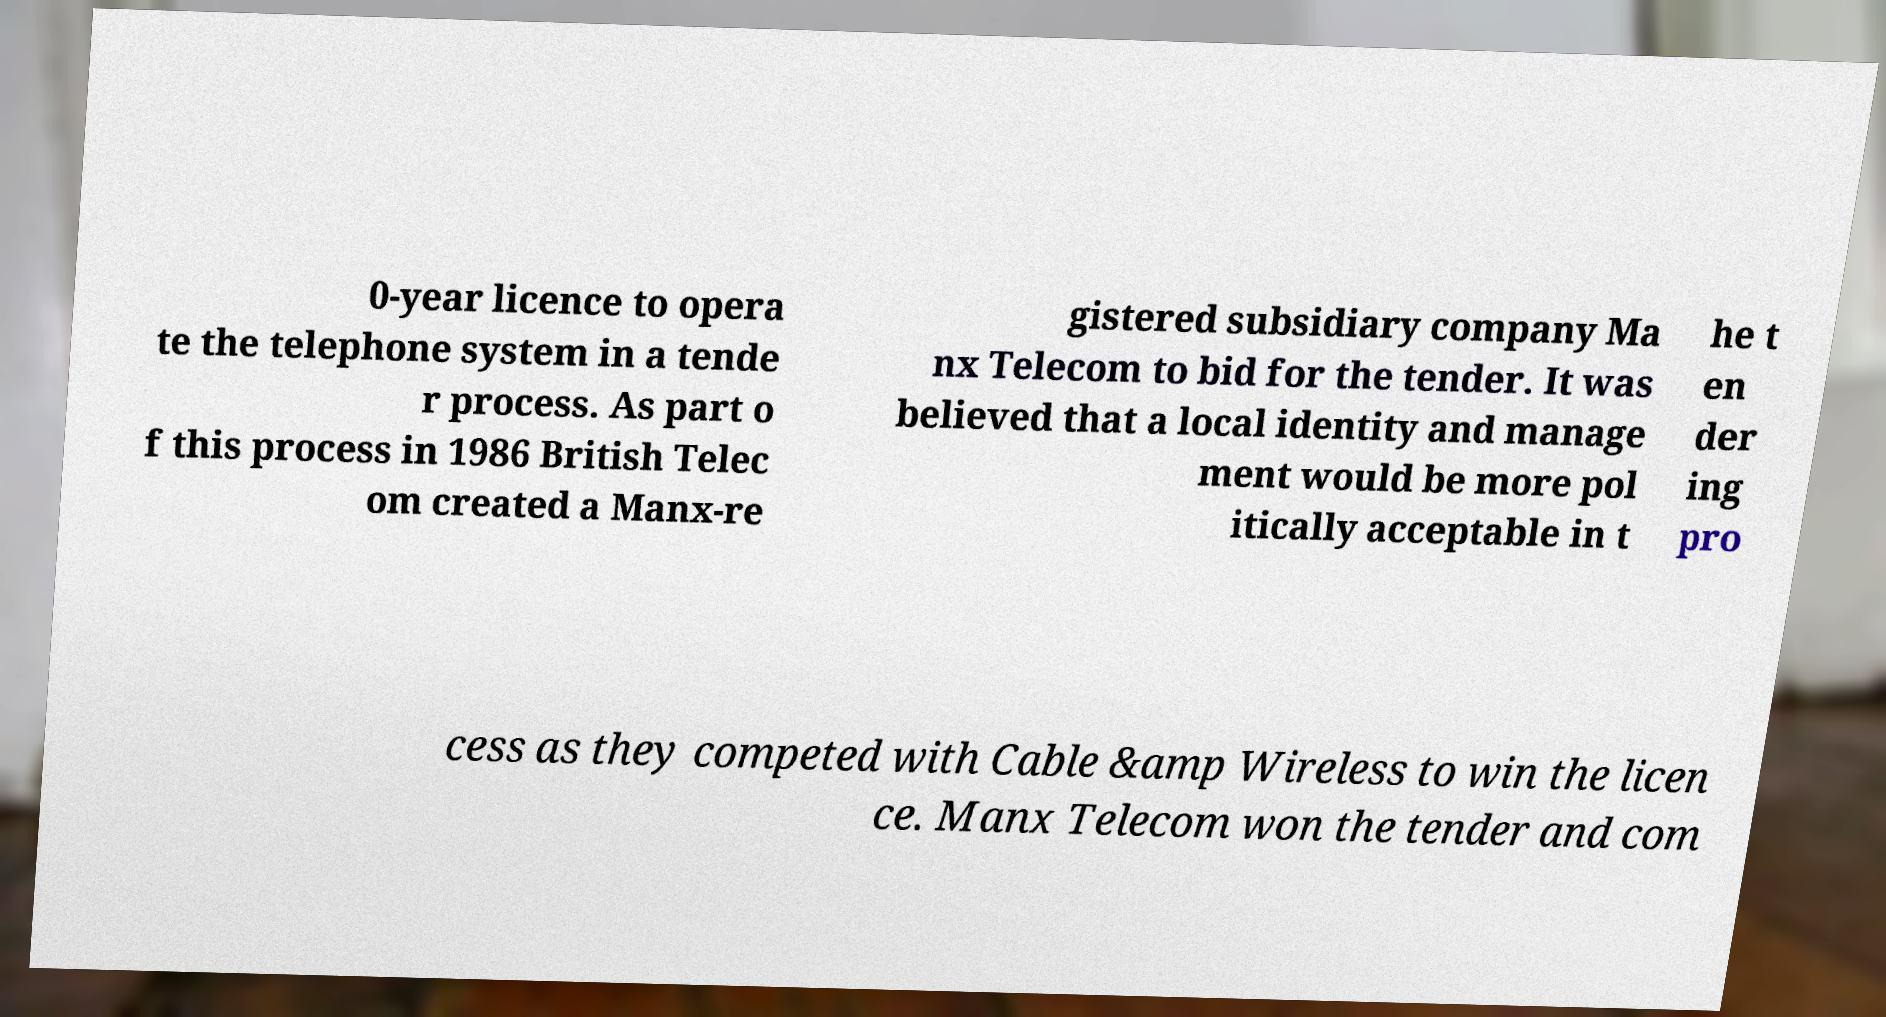What messages or text are displayed in this image? I need them in a readable, typed format. 0-year licence to opera te the telephone system in a tende r process. As part o f this process in 1986 British Telec om created a Manx-re gistered subsidiary company Ma nx Telecom to bid for the tender. It was believed that a local identity and manage ment would be more pol itically acceptable in t he t en der ing pro cess as they competed with Cable &amp Wireless to win the licen ce. Manx Telecom won the tender and com 